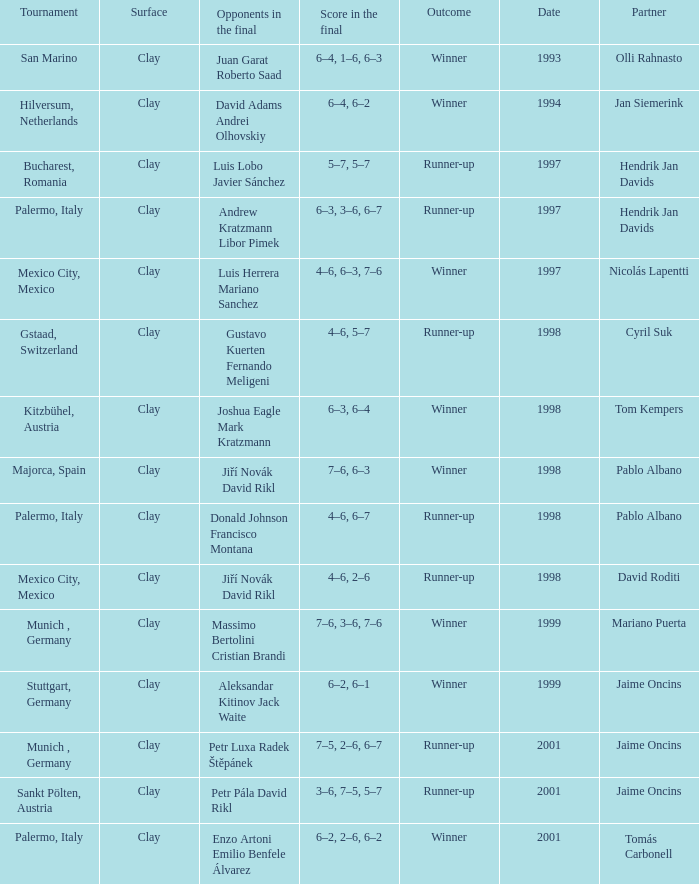Who are the Opponents in the final prior to 1998 in the Bucharest, Romania Tournament? Luis Lobo Javier Sánchez. Can you parse all the data within this table? {'header': ['Tournament', 'Surface', 'Opponents in the final', 'Score in the final', 'Outcome', 'Date', 'Partner'], 'rows': [['San Marino', 'Clay', 'Juan Garat Roberto Saad', '6–4, 1–6, 6–3', 'Winner', '1993', 'Olli Rahnasto'], ['Hilversum, Netherlands', 'Clay', 'David Adams Andrei Olhovskiy', '6–4, 6–2', 'Winner', '1994', 'Jan Siemerink'], ['Bucharest, Romania', 'Clay', 'Luis Lobo Javier Sánchez', '5–7, 5–7', 'Runner-up', '1997', 'Hendrik Jan Davids'], ['Palermo, Italy', 'Clay', 'Andrew Kratzmann Libor Pimek', '6–3, 3–6, 6–7', 'Runner-up', '1997', 'Hendrik Jan Davids'], ['Mexico City, Mexico', 'Clay', 'Luis Herrera Mariano Sanchez', '4–6, 6–3, 7–6', 'Winner', '1997', 'Nicolás Lapentti'], ['Gstaad, Switzerland', 'Clay', 'Gustavo Kuerten Fernando Meligeni', '4–6, 5–7', 'Runner-up', '1998', 'Cyril Suk'], ['Kitzbühel, Austria', 'Clay', 'Joshua Eagle Mark Kratzmann', '6–3, 6–4', 'Winner', '1998', 'Tom Kempers'], ['Majorca, Spain', 'Clay', 'Jiří Novák David Rikl', '7–6, 6–3', 'Winner', '1998', 'Pablo Albano'], ['Palermo, Italy', 'Clay', 'Donald Johnson Francisco Montana', '4–6, 6–7', 'Runner-up', '1998', 'Pablo Albano'], ['Mexico City, Mexico', 'Clay', 'Jiří Novák David Rikl', '4–6, 2–6', 'Runner-up', '1998', 'David Roditi'], ['Munich , Germany', 'Clay', 'Massimo Bertolini Cristian Brandi', '7–6, 3–6, 7–6', 'Winner', '1999', 'Mariano Puerta'], ['Stuttgart, Germany', 'Clay', 'Aleksandar Kitinov Jack Waite', '6–2, 6–1', 'Winner', '1999', 'Jaime Oncins'], ['Munich , Germany', 'Clay', 'Petr Luxa Radek Štěpánek', '7–5, 2–6, 6–7', 'Runner-up', '2001', 'Jaime Oncins'], ['Sankt Pölten, Austria', 'Clay', 'Petr Pála David Rikl', '3–6, 7–5, 5–7', 'Runner-up', '2001', 'Jaime Oncins'], ['Palermo, Italy', 'Clay', 'Enzo Artoni Emilio Benfele Álvarez', '6–2, 2–6, 6–2', 'Winner', '2001', 'Tomás Carbonell']]} 